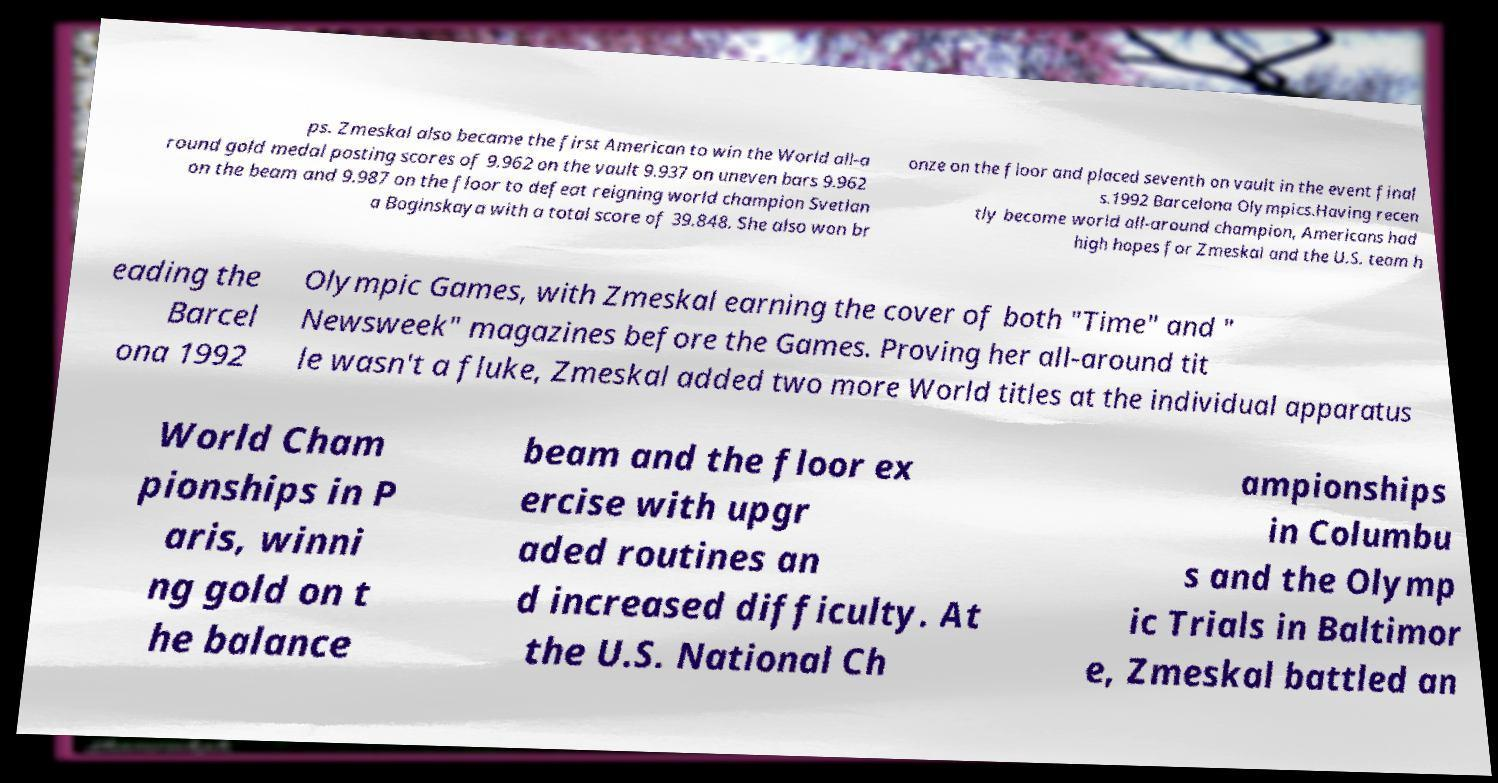For documentation purposes, I need the text within this image transcribed. Could you provide that? ps. Zmeskal also became the first American to win the World all-a round gold medal posting scores of 9.962 on the vault 9.937 on uneven bars 9.962 on the beam and 9.987 on the floor to defeat reigning world champion Svetlan a Boginskaya with a total score of 39.848. She also won br onze on the floor and placed seventh on vault in the event final s.1992 Barcelona Olympics.Having recen tly become world all-around champion, Americans had high hopes for Zmeskal and the U.S. team h eading the Barcel ona 1992 Olympic Games, with Zmeskal earning the cover of both "Time" and " Newsweek" magazines before the Games. Proving her all-around tit le wasn't a fluke, Zmeskal added two more World titles at the individual apparatus World Cham pionships in P aris, winni ng gold on t he balance beam and the floor ex ercise with upgr aded routines an d increased difficulty. At the U.S. National Ch ampionships in Columbu s and the Olymp ic Trials in Baltimor e, Zmeskal battled an 